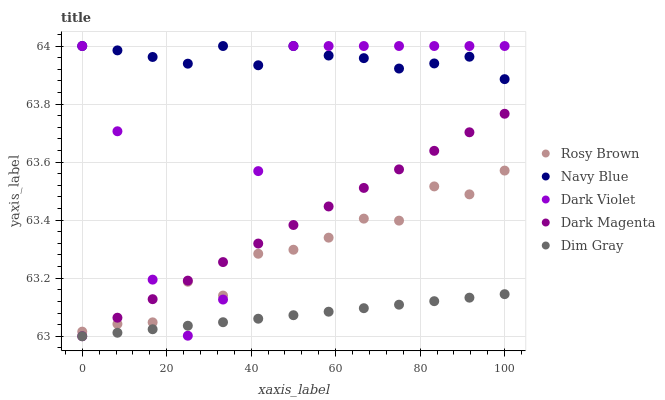Does Dim Gray have the minimum area under the curve?
Answer yes or no. Yes. Does Navy Blue have the maximum area under the curve?
Answer yes or no. Yes. Does Rosy Brown have the minimum area under the curve?
Answer yes or no. No. Does Rosy Brown have the maximum area under the curve?
Answer yes or no. No. Is Dim Gray the smoothest?
Answer yes or no. Yes. Is Dark Violet the roughest?
Answer yes or no. Yes. Is Rosy Brown the smoothest?
Answer yes or no. No. Is Rosy Brown the roughest?
Answer yes or no. No. Does Dim Gray have the lowest value?
Answer yes or no. Yes. Does Rosy Brown have the lowest value?
Answer yes or no. No. Does Dark Violet have the highest value?
Answer yes or no. Yes. Does Rosy Brown have the highest value?
Answer yes or no. No. Is Dim Gray less than Rosy Brown?
Answer yes or no. Yes. Is Navy Blue greater than Dim Gray?
Answer yes or no. Yes. Does Dim Gray intersect Dark Magenta?
Answer yes or no. Yes. Is Dim Gray less than Dark Magenta?
Answer yes or no. No. Is Dim Gray greater than Dark Magenta?
Answer yes or no. No. Does Dim Gray intersect Rosy Brown?
Answer yes or no. No. 